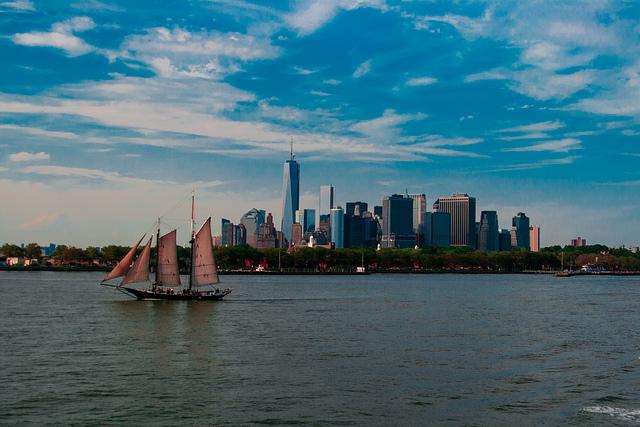How many stacks can you count?
Be succinct. 0. Is the water calm?
Give a very brief answer. Yes. What is there a lot of in the background?
Give a very brief answer. Buildings. What is tall in the background?
Be succinct. Buildings. Is the water high?
Short answer required. No. What kind of boat is in the water?
Short answer required. Sailboat. Do you see anyone wearing flipper?
Quick response, please. No. What kind of ship is out in the water?
Keep it brief. Sailboat. How many sails are on the boat?
Answer briefly. 4. What are they learning to do?
Short answer required. Sail. What kind of boat is it?
Answer briefly. Sailboat. What city is this?
Concise answer only. New york. What is the boat producing in the water?
Write a very short answer. Waves. Where are the boats going too?
Concise answer only. City. Is this picture colorful?
Keep it brief. Yes. Is a boat to arrive?
Quick response, please. Yes. Do you see a bridge?
Answer briefly. No. What method of transportation is shown?
Be succinct. Boat. How many boats are in the water?
Answer briefly. 1. Is there any boat seen?
Quick response, please. Yes. Could the Vista in the background be described as idyllic?
Answer briefly. Yes. Is there sharks in the water?
Keep it brief. No. How are they moving or controlling the boat?
Concise answer only. Wind. What color is the boat?
Short answer required. Black. Where are the boards?
Give a very brief answer. On boat. What shape would the sail be in if it was unfurled on this boat?
Keep it brief. Triangle. Where was this photo taken?
Quick response, please. Chicago. Are there birds in the water?
Answer briefly. No. 